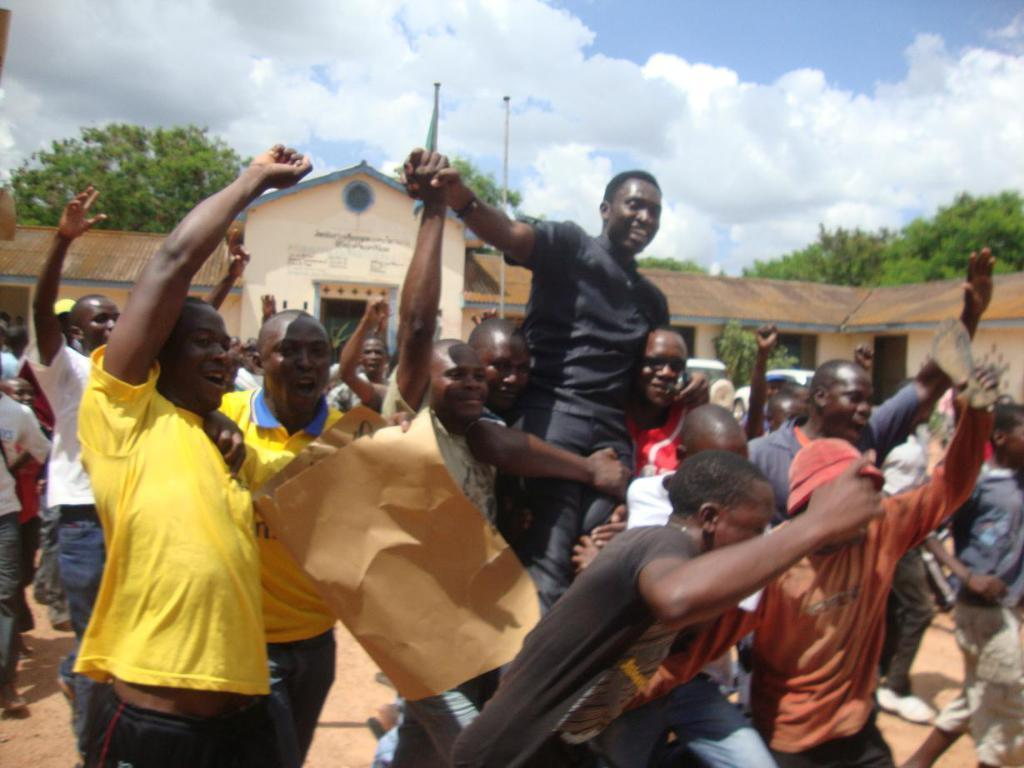What is happening in the middle of the image? There is a group of people in the middle of the image. What is the mood or emotion of the people in the image? The people are laughing. What can be seen in the background of the image? There is a building and trees in the background of the image. What is visible at the top of the image? The sky is visible at the top of the image. What type of copper material is being used for transport in the image? There is no copper material or transportation device present in the image. 